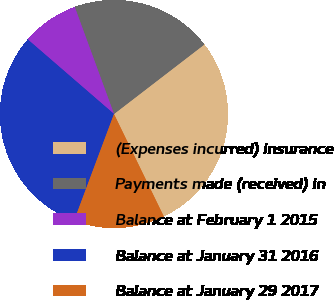<chart> <loc_0><loc_0><loc_500><loc_500><pie_chart><fcel>(Expenses incurred) insurance<fcel>Payments made (received) in<fcel>Balance at February 1 2015<fcel>Balance at January 31 2016<fcel>Balance at January 29 2017<nl><fcel>28.23%<fcel>20.16%<fcel>8.06%<fcel>30.65%<fcel>12.9%<nl></chart> 